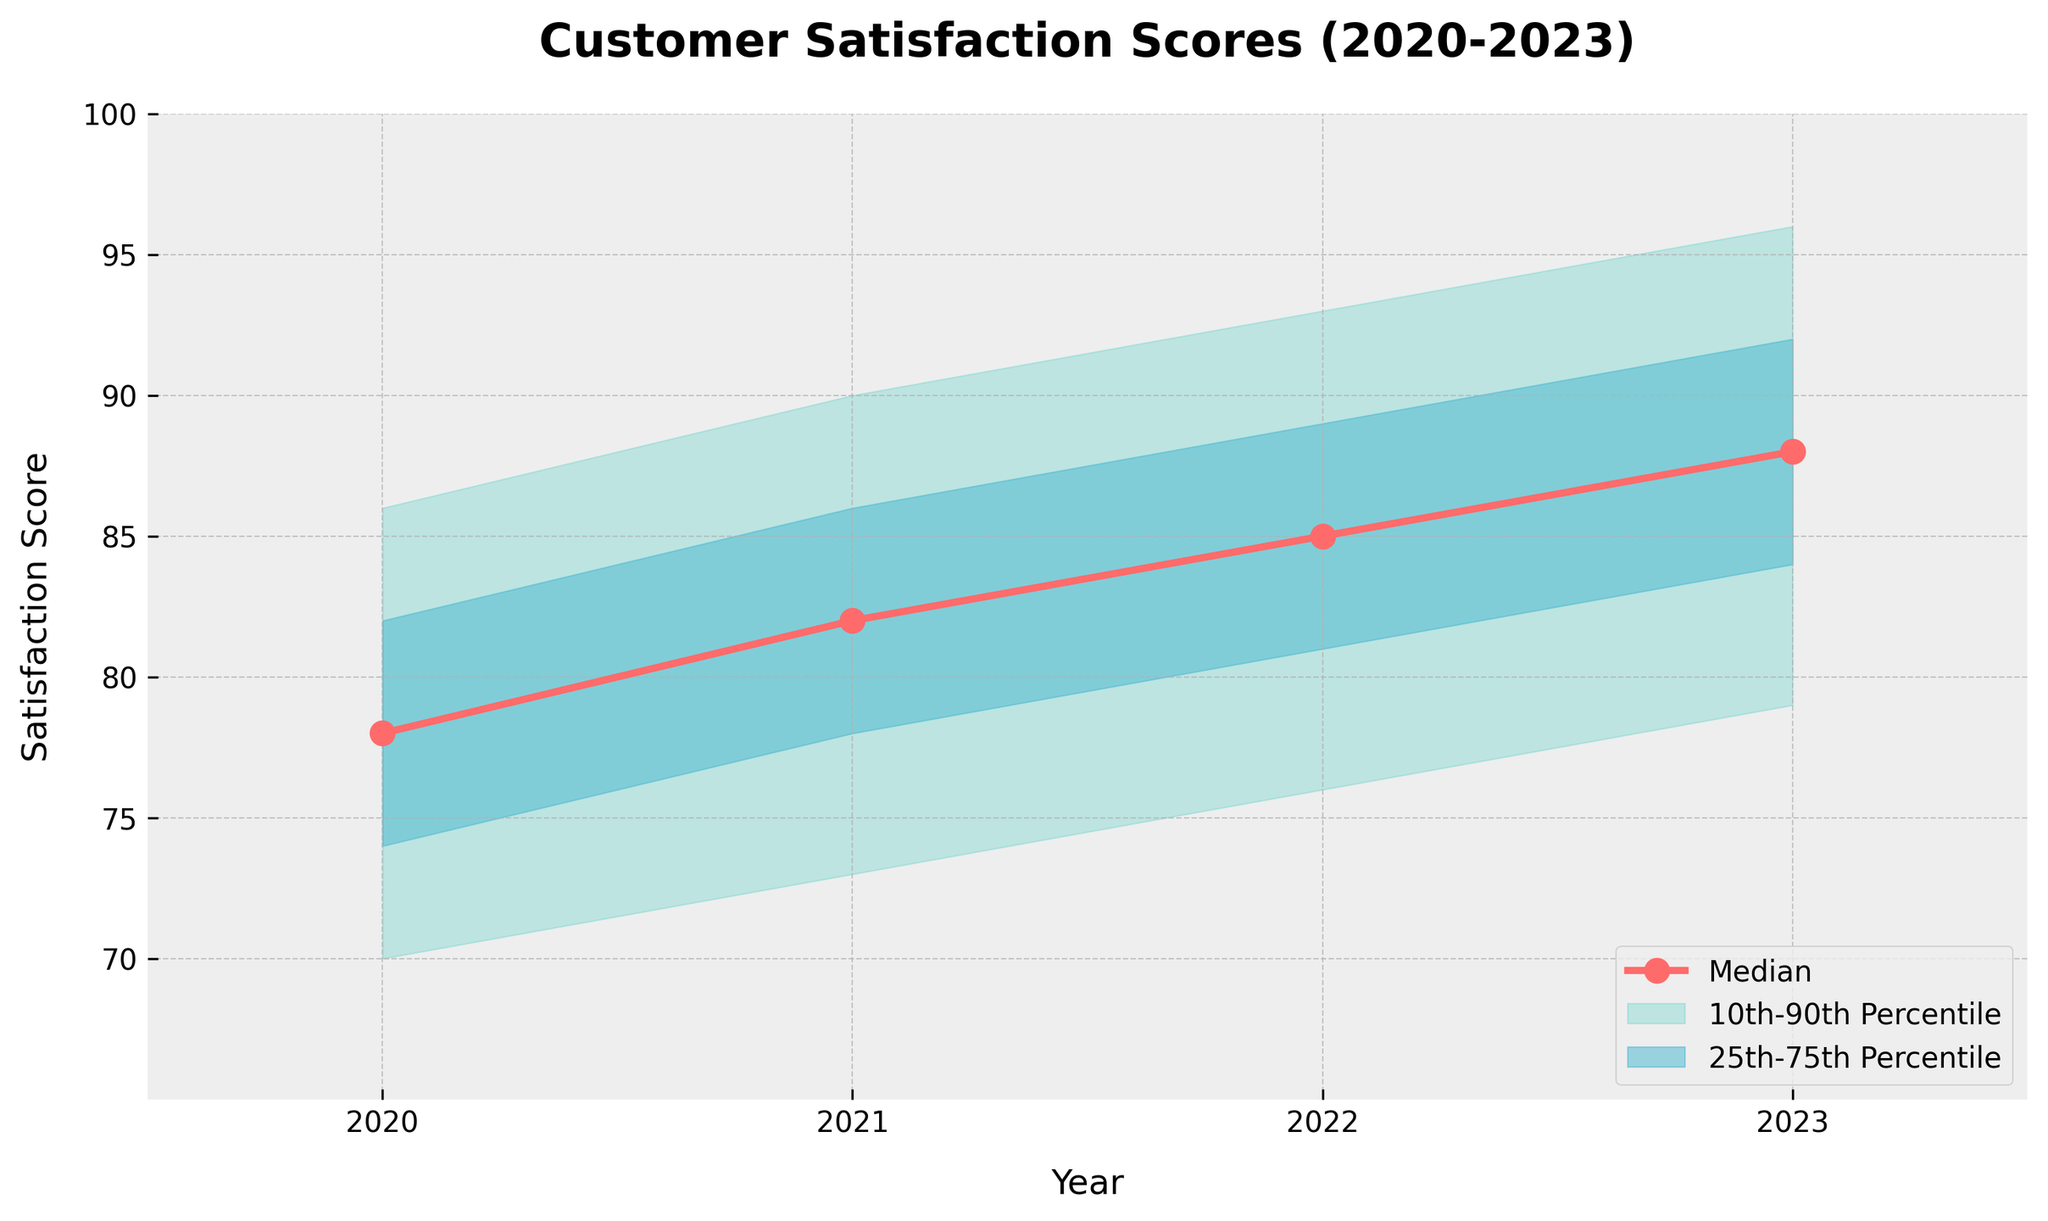What's the title of the figure? The title is displayed at the top of the figure and provides a summary of the content.
Answer: Customer Satisfaction Scores (2020-2023) How many years are compared in the figure? Count the distinct data points along the x-axis, which represent different years.
Answer: 4 What's the median customer satisfaction score for 2022? Look at the value of the median line (marked by circles) for the year 2022.
Answer: 85 What is the range of the 10th to 90th percentiles for 2023? Identify the shaded region labeled "10th-90th Percentile" and note its upper and lower bounds for the year 2023.
Answer: 79-96 Which year has the highest median customer satisfaction score? Compare the height of the median line (marked by the circles) for each year and identify the highest value.
Answer: 2023 What's the difference between the upper 90th percentile and lower 10th percentile for the year 2021? Subtract the lower 10th percentile value from the upper 90th percentile value for 2021.
Answer: 90 - 73 = 17 What's the improvement in the median customer satisfaction score from 2020 to 2023? Subtract the median value of 2020 from that of 2023.
Answer: 88 - 78 = 10 What's the average median satisfaction score over the 4 years? Sum the median values for all years and divide by the number of years (4). (78 + 82 + 85 + 88) / 4 = 333 / 4 = 83.25
Answer: 83.25 